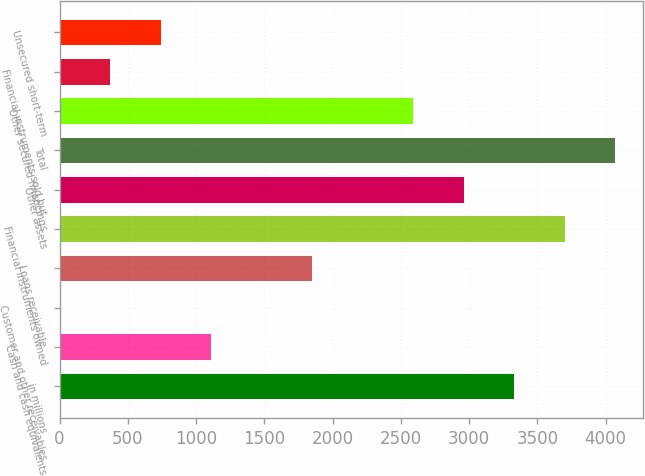<chart> <loc_0><loc_0><loc_500><loc_500><bar_chart><fcel>in millions<fcel>Cash and cash equivalents<fcel>Customer and other receivables<fcel>Loans receivable<fcel>Financial instruments owned<fcel>Other assets<fcel>Total<fcel>Other secured financings<fcel>Financial instruments sold but<fcel>Unsecured short-term<nl><fcel>3330.2<fcel>1111.4<fcel>2<fcel>1851<fcel>3700<fcel>2960.4<fcel>4069.8<fcel>2590.6<fcel>371.8<fcel>741.6<nl></chart> 